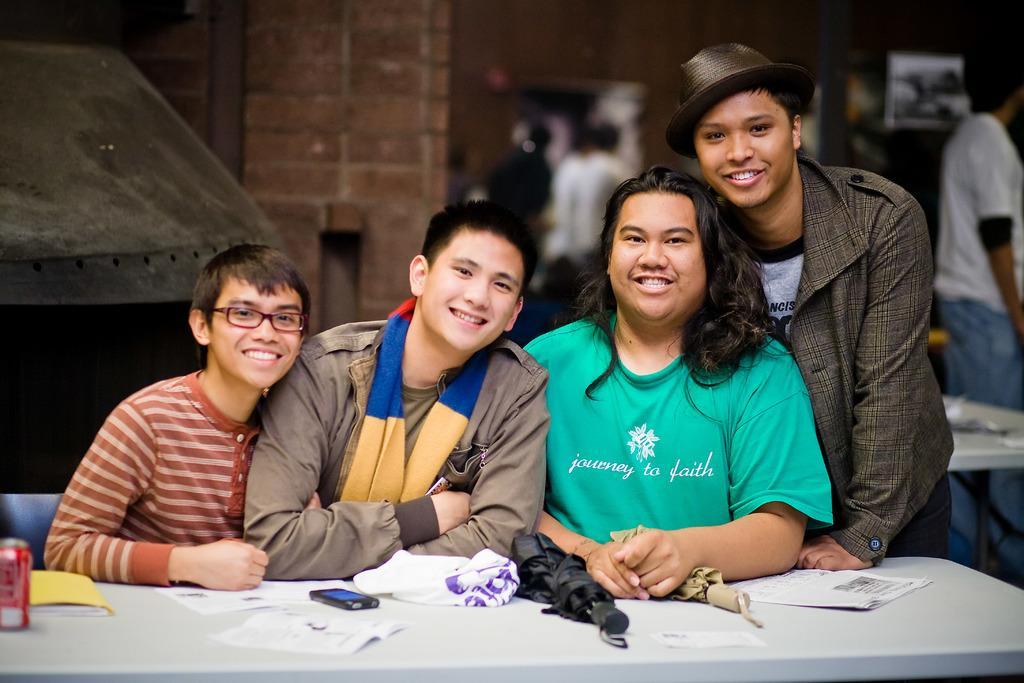Describe this image in one or two sentences. In this picture we can see four persons are smiling in the front, there is a table at the bottom, there are umbrellas, a tin, a mobile phone, papers, a cover and a file placed on the table, in the background we can see some people, a table and a wall, there is a blurry background. 